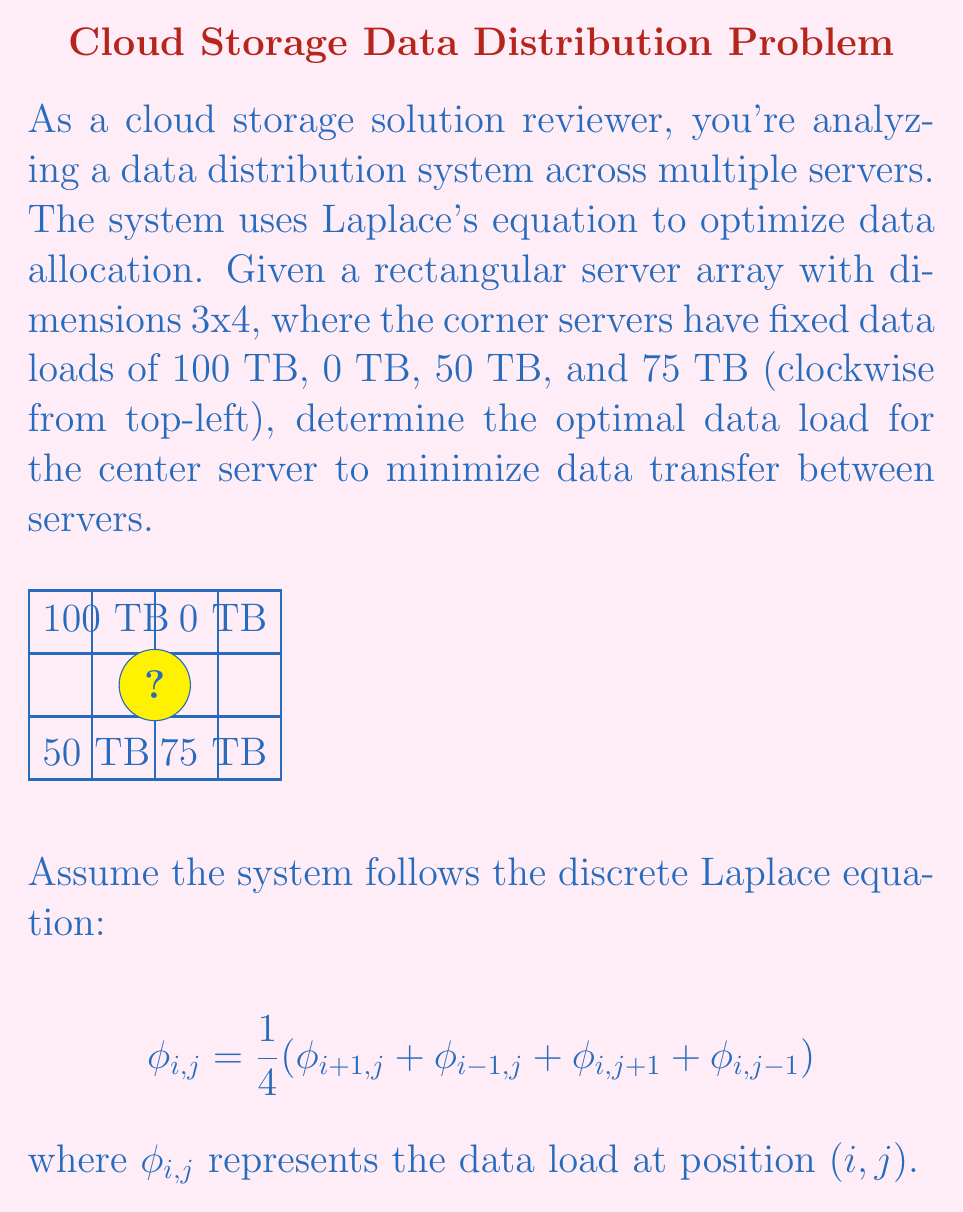Show me your answer to this math problem. To solve this problem, we'll use the discrete Laplace equation and the given boundary conditions. Let's follow these steps:

1) First, we need to set up our grid. We have a 3x4 array, so we'll number our rows 0 to 2 and columns 0 to 3.

2) We're interested in the center server, which is at position (1,1) in our grid.

3) The discrete Laplace equation for this position is:

   $$\phi_{1,1} = \frac{1}{4}(\phi_{2,1} + \phi_{0,1} + \phi_{1,2} + \phi_{1,0})$$

4) We don't know the values for $\phi_{2,1}$, $\phi_{0,1}$, $\phi_{1,2}$, and $\phi_{1,0}$, but we can approximate them using the known corner values:

   $\phi_{2,1} \approx \frac{50 + 75}{2} = 62.5$
   $\phi_{0,1} \approx \frac{100 + 0}{2} = 50$
   $\phi_{1,2} \approx \frac{0 + 75}{2} = 37.5$
   $\phi_{1,0} \approx \frac{100 + 50}{2} = 75$

5) Now we can substitute these values into our equation:

   $$\phi_{1,1} = \frac{1}{4}(62.5 + 50 + 37.5 + 75)$$

6) Simplifying:

   $$\phi_{1,1} = \frac{225}{4} = 56.25$$

Therefore, the optimal data load for the center server is 56.25 TB.
Answer: 56.25 TB 